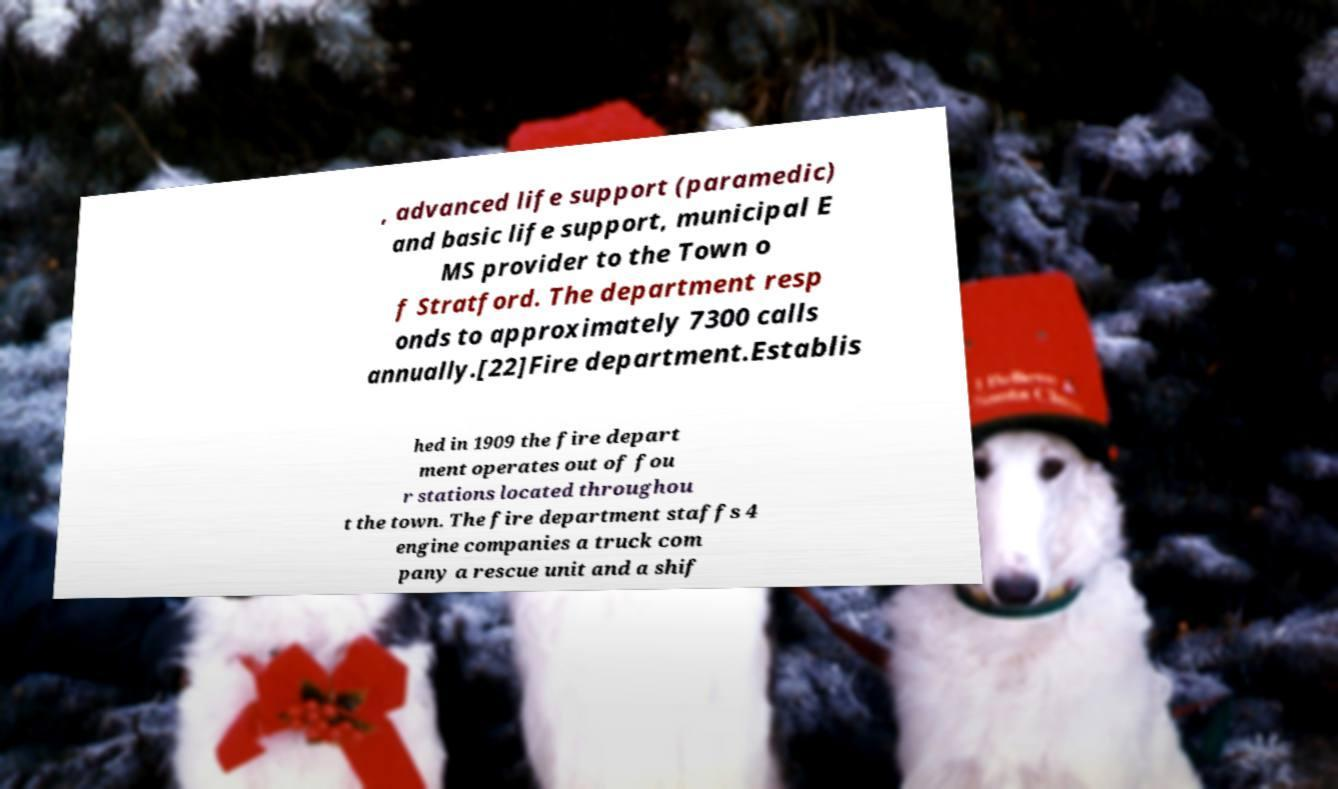Can you read and provide the text displayed in the image?This photo seems to have some interesting text. Can you extract and type it out for me? , advanced life support (paramedic) and basic life support, municipal E MS provider to the Town o f Stratford. The department resp onds to approximately 7300 calls annually.[22]Fire department.Establis hed in 1909 the fire depart ment operates out of fou r stations located throughou t the town. The fire department staffs 4 engine companies a truck com pany a rescue unit and a shif 